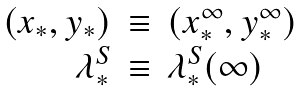<formula> <loc_0><loc_0><loc_500><loc_500>\begin{array} { r c l } ( x _ { * } , y _ { * } ) & \equiv & ( x ^ { \infty } _ { * } , y ^ { \infty } _ { * } ) \\ \lambda ^ { S } _ { * } & \equiv & \lambda ^ { S } _ { * } ( \infty ) \end{array}</formula> 